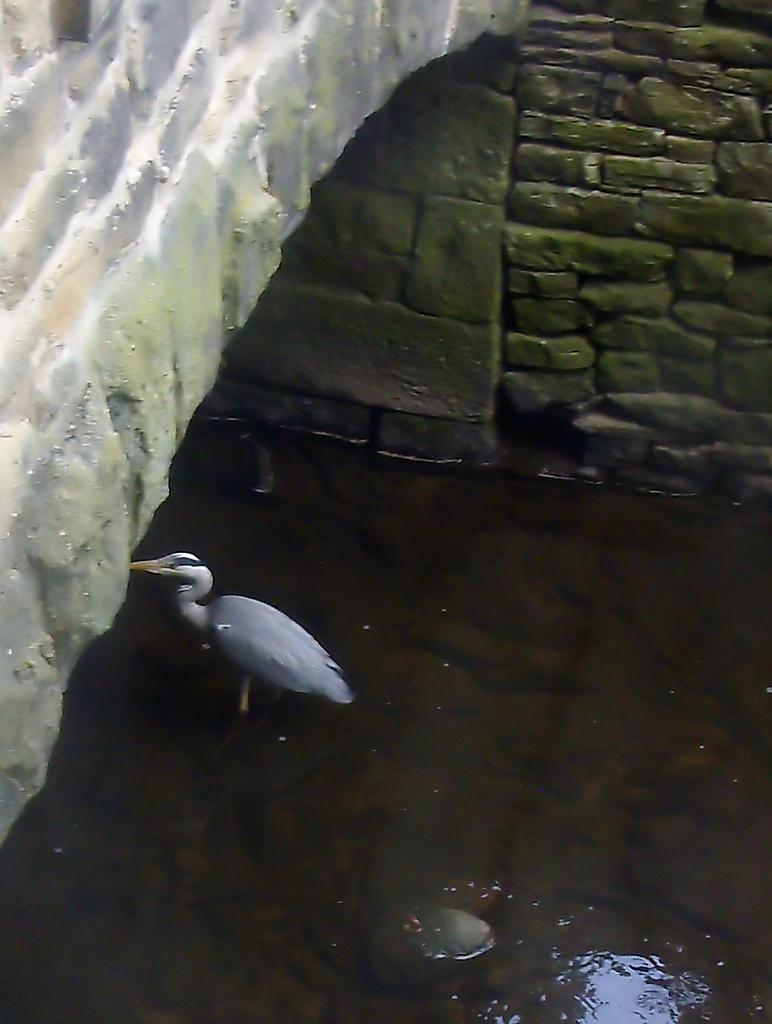What is at the bottom of the image? There is water at the bottom of the image. What type of animal can be seen in the image? There is a bird in the image. What can be seen in the background of the image? There is a wall in the background of the image. What type of twig is the bird holding in the image? There is no twig present in the image; the bird is not holding anything. Can you tell me what game the bird is playing in the image? There is no game being played in the image; it simply features a bird and water. 